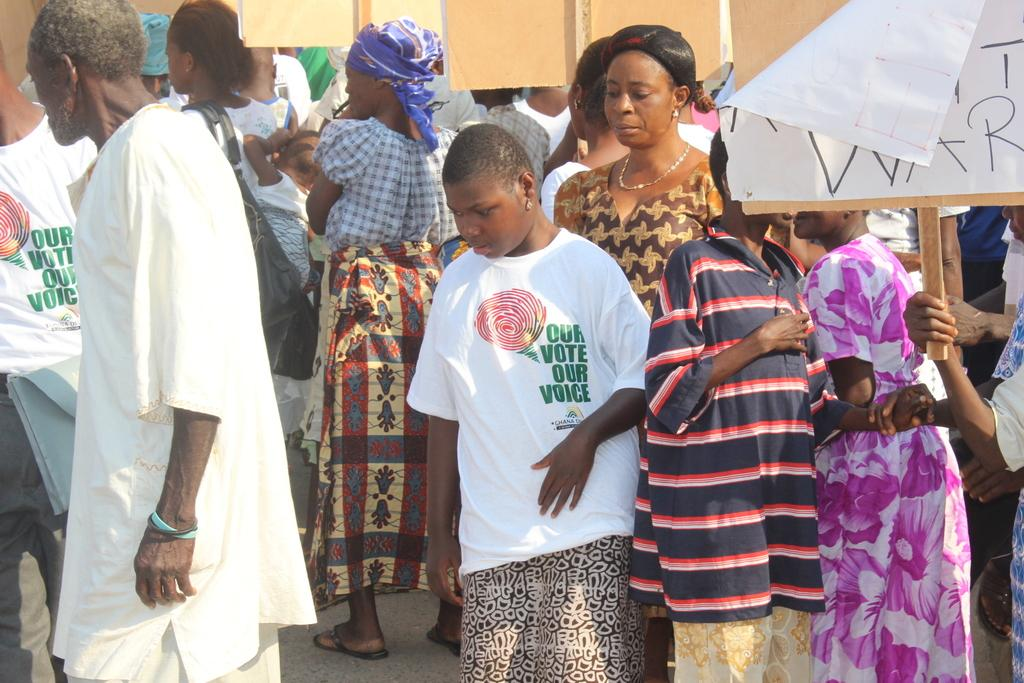What are the people in the image doing? The people in the image are standing on the road. What are some of the people holding? Some of the people are holding boards. What can be observed about the clothing of certain individuals in the image? There are people wearing white T-shirts in the image. What is written on the white T-shirts? The white T-shirts have text on them. What type of button can be seen on the white T-shirts in the image? There is no button present on the white T-shirts in the image. 